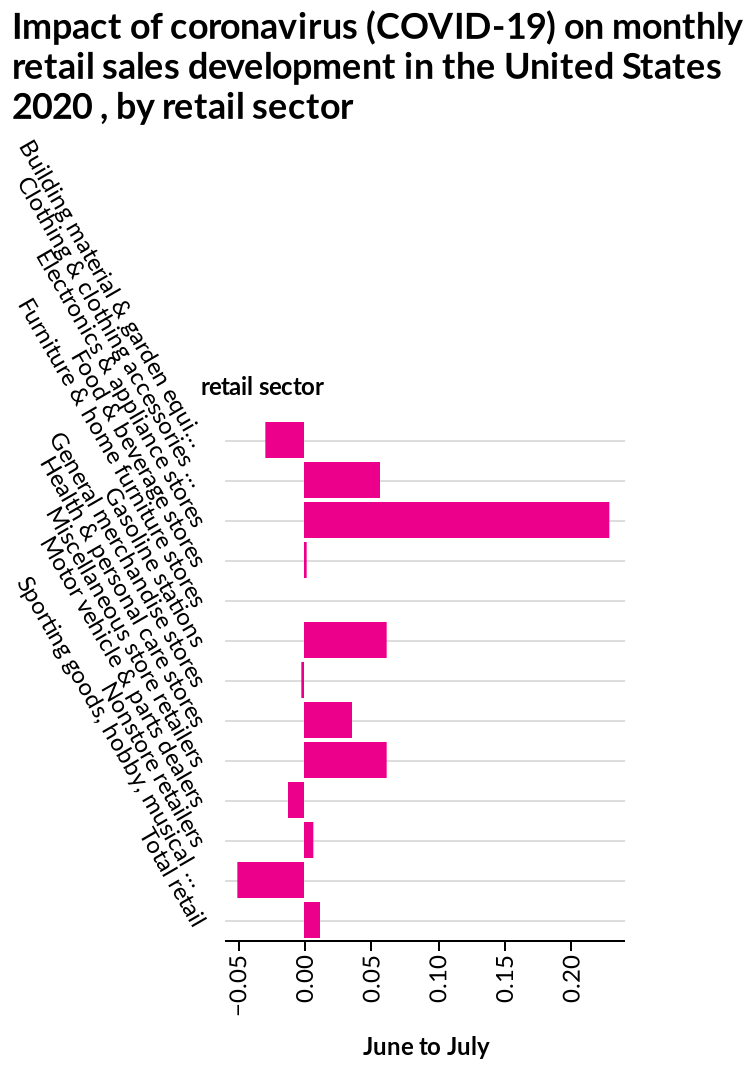<image>
What is the name of the bar diagram? The bar diagram is named "Impact of coronavirus (COVID-19) on monthly retail sales development in the United States 2020, by retail sector." What does the bar diagram depict? The bar diagram depicts the impact of the coronavirus pandemic on monthly retail sales development in the United States in 2020, divided by retail sectors. Does the bar diagram depict the impact of the coronavirus pandemic on daily retail sales development in the United States in 2019, divided by retail sectors? No.The bar diagram depicts the impact of the coronavirus pandemic on monthly retail sales development in the United States in 2020, divided by retail sectors. 